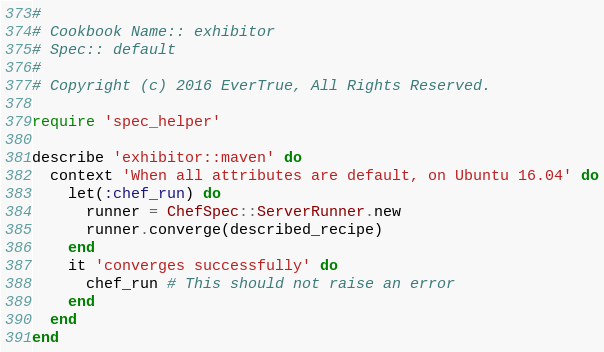<code> <loc_0><loc_0><loc_500><loc_500><_Ruby_>#
# Cookbook Name:: exhibitor
# Spec:: default
#
# Copyright (c) 2016 EverTrue, All Rights Reserved.

require 'spec_helper'

describe 'exhibitor::maven' do
  context 'When all attributes are default, on Ubuntu 16.04' do
    let(:chef_run) do
      runner = ChefSpec::ServerRunner.new
      runner.converge(described_recipe)
    end
    it 'converges successfully' do
      chef_run # This should not raise an error
    end
  end
end
</code> 